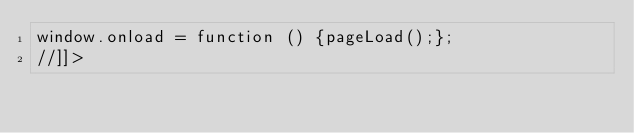Convert code to text. <code><loc_0><loc_0><loc_500><loc_500><_HTML_>window.onload = function () {pageLoad();};
//]]></code> 